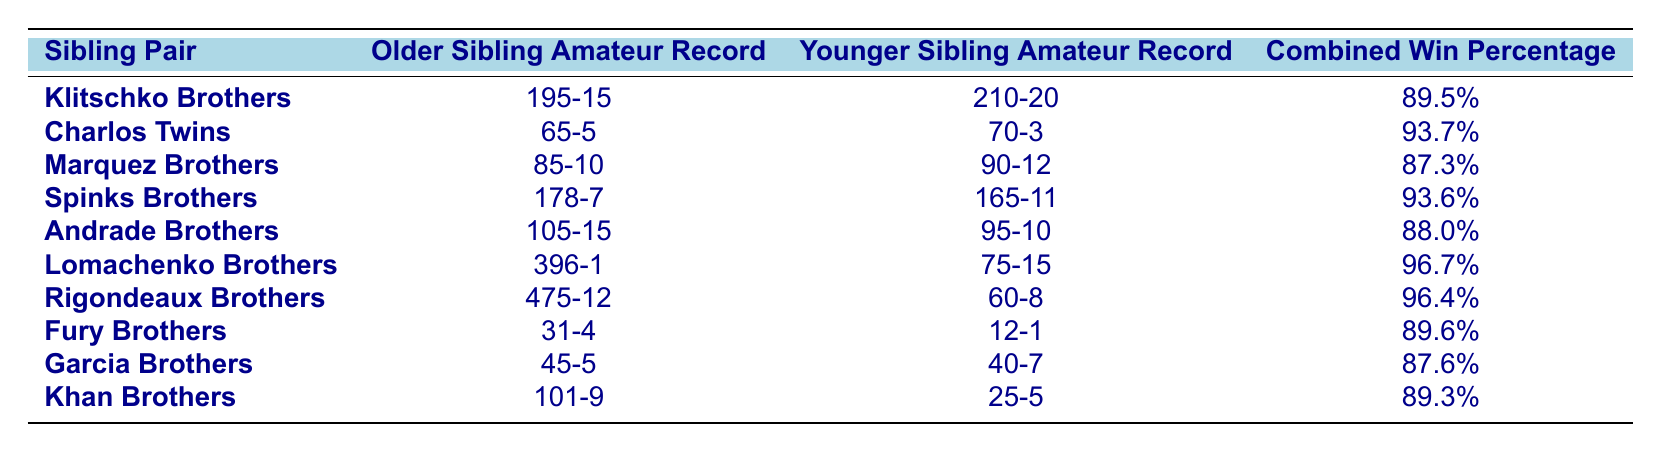What is the combined win percentage of the Lomachenko Brothers? The table lists the Lomachenko Brothers with a combined win percentage of 96.7%.
Answer: 96.7% Which sibling pair has the highest combined win percentage? From the table, the Lomachenko Brothers have the highest combined win percentage of 96.7%.
Answer: Lomachenko Brothers How many wins does the older sibling of the Klitschko Brothers have? The older sibling of the Klitschko Brothers has an amateur record of 195 wins.
Answer: 195 What is the win-loss record of the younger sibling in the Spinks Brothers? The table shows that the younger sibling in the Spinks Brothers has an amateur record of 165 wins and 11 losses.
Answer: 165-11 What is the difference in the number of wins between the Charlos Twins? The older sibling has 65 wins and the younger sibling has 70 wins. The difference is 70 - 65 = 5 wins.
Answer: 5 wins Are the Garcia Brothers' combined win percentages above 85%? The Garcia Brothers have a combined win percentage of 87.6%, which is above 85%.
Answer: Yes Which sibling pair has the lowest win-loss record for the younger sibling? The Fury Brothers have the lowest win-loss record for the younger sibling with 12 wins and 1 loss.
Answer: Fury Brothers What is the total number of wins recorded by both siblings in the Andrade Brothers? The older sibling has 105 wins and the younger sibling has 95 wins. The total is 105 + 95 = 200 wins.
Answer: 200 wins Is the win-loss record of the Rigondeaux Brothers better than that of the Marquez Brothers? The Rigondeaux Brothers have a record of 475-12 (win percentage of 96.4%) while the Marquez Brothers have 85-10 (win percentage of 87.3%). Thus, Rigondeaux Brothers have a better record.
Answer: Yes What is the average number of losses for the younger siblings across all pairs? The younger siblings have records of 20, 3, 12, 11, 10, 15, 8, 1, 7, and 5 losses, respectively. The average is (20 + 3 + 12 + 11 + 10 + 15 + 8 + 1 + 7 + 5) / 10 = 9.2 losses.
Answer: 9.2 losses 